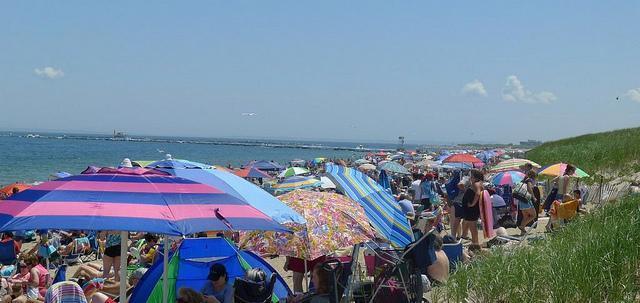How many umbrellas are in the picture?
Give a very brief answer. 5. 